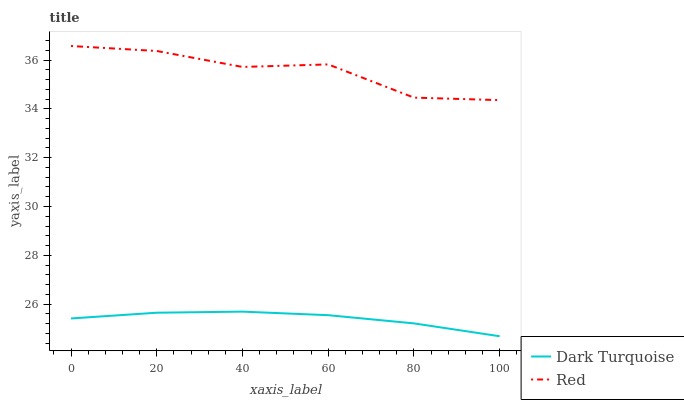Does Dark Turquoise have the minimum area under the curve?
Answer yes or no. Yes. Does Red have the maximum area under the curve?
Answer yes or no. Yes. Does Red have the minimum area under the curve?
Answer yes or no. No. Is Dark Turquoise the smoothest?
Answer yes or no. Yes. Is Red the roughest?
Answer yes or no. Yes. Is Red the smoothest?
Answer yes or no. No. Does Dark Turquoise have the lowest value?
Answer yes or no. Yes. Does Red have the lowest value?
Answer yes or no. No. Does Red have the highest value?
Answer yes or no. Yes. Is Dark Turquoise less than Red?
Answer yes or no. Yes. Is Red greater than Dark Turquoise?
Answer yes or no. Yes. Does Dark Turquoise intersect Red?
Answer yes or no. No. 